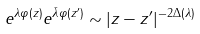Convert formula to latex. <formula><loc_0><loc_0><loc_500><loc_500>e ^ { \lambda \varphi ( z ) } e ^ { \bar { \lambda } \varphi ( z ^ { \prime } ) } \sim | z - z ^ { \prime } | ^ { - 2 \Delta ( \lambda ) }</formula> 